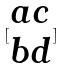<formula> <loc_0><loc_0><loc_500><loc_500>[ \begin{matrix} a c \\ b d \end{matrix} ]</formula> 